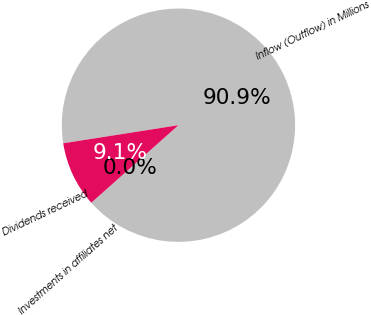Convert chart to OTSL. <chart><loc_0><loc_0><loc_500><loc_500><pie_chart><fcel>Inflow (Outflow) in Millions<fcel>Investments in affiliates net<fcel>Dividends received<nl><fcel>90.9%<fcel>0.0%<fcel>9.09%<nl></chart> 